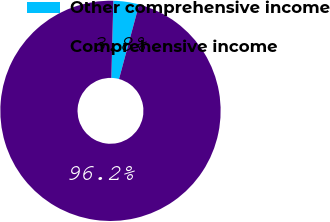Convert chart to OTSL. <chart><loc_0><loc_0><loc_500><loc_500><pie_chart><fcel>Other comprehensive income<fcel>Comprehensive income<nl><fcel>3.77%<fcel>96.23%<nl></chart> 